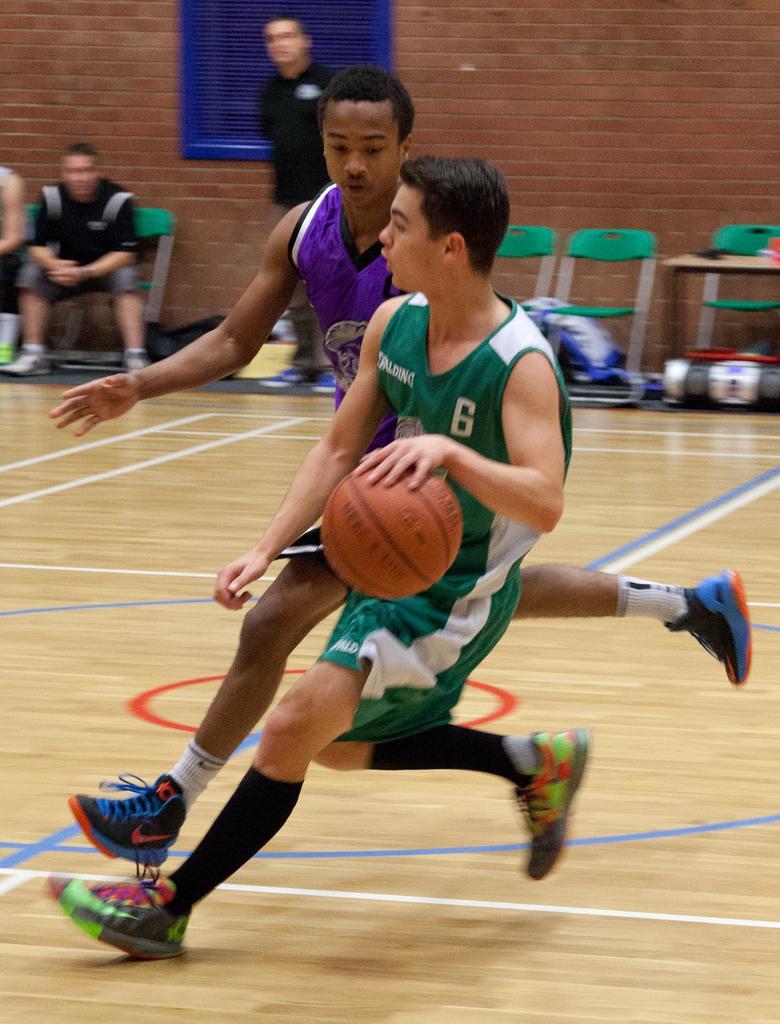In one or two sentences, can you explain what this image depicts? In front of the image there is a person running on the floor by holding the ball. Behind him there is another person. There are two people sitting on the chairs. Beside them there is a person standing. On the right side of the image there are chairs and a few other objects. In the background of the image there is a board on the wall. 